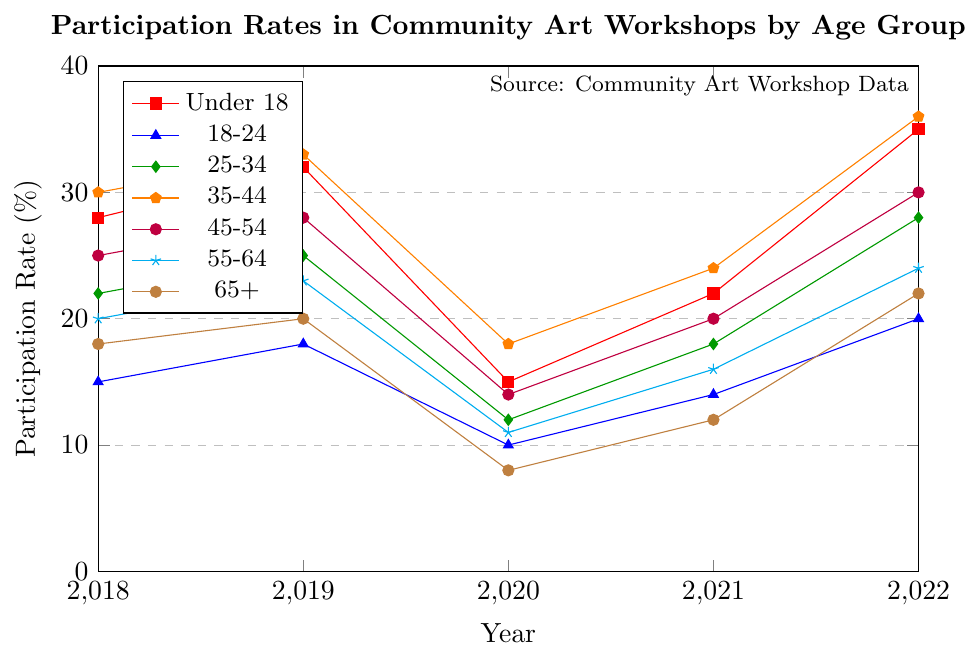What's the trend for the participation rate of the "Under 18" age group over the years? Start by observing the line plot corresponding to the "Under 18" age group, marked with a specific color. In 2018, the participation rate for the "Under 18" age group is at 28%, which then rises to 32% in 2019. It significantly drops to 15% in 2020, then recovers slightly to 22% in 2021, and finally reaches its peak at 35% in 2022.
Answer: Increasing with fluctuations Which age group shows the largest increase in participation rate from 2021 to 2022? Identify the segment from 2021 to 2022 for each age group. For Under 18, the rise is from 22% to 35% (13%). For 18-24, it's from 14% to 20% (6%). For 25-34, it's from 18% to 28% (10%). For 35-44, it's from 24% to 36% (12%). For 45-54, it's from 20% to 30% (10%). For 55-64, it's from 16% to 24% (8%). For 65+, it's from 12% to 22% (10%). The "Under 18" group has the highest increase of 13%.
Answer: Under 18 In which year did the 65+ age group have the lowest participation rate? Trace the line corresponding to the 65+ age group and identify the point with the lowest value. The years with the respective values are 2018 (18%), 2019 (20%), 2020 (8%), 2021 (12%), and 2022 (22%). The lowest value is 8%, which occurs in 2020.
Answer: 2020 What is the average participation rate for the 35-44 age group over the 5 years? Add the participation rates for the 35-44 age group from 2018 to 2022: 30%, 33%, 18%, 24%, and 36%. The sum is 30 + 33 + 18 + 24 + 36 = 141. The average is then 141 / 5 = 28.2%.
Answer: 28.2% Which age group has the most consistent participation rate from 2018 to 2022? Evaluate the fluctuation (difference between highest and lowest rates) for each age group. Under 18: 35%-15%=20%, 18-24: 20%-10%=10%, 25-34: 28%-12%=16%, 35-44: 36%-18%=18%, 45-54: 30%-14%=16%, 55-64: 24%-11%=13%, 65+: 22%-8%=14%. The 18-24 age group has the smallest range, indicating the most consistent participation.
Answer: 18-24 How did the pandemic year (2020) affect the participation rates across all age groups? Look at the participation rates for all age groups in 2020. The values are: Under 18 (15%), 18-24 (10%), 25-34 (12%), 35-44 (18%), 45-54 (14%), 55-64 (11%), 65+ (8%). Compared to other years, 2020 generally shows lower participation rates, suggesting a significant drop in participation across all age groups during the pandemic year.
Answer: Decreased across all What is the difference in the participation rate between the oldest (65+) and the youngest (Under 18) age groups in 2022? For 2022, the participation rates are 35% for Under 18 and 22% for 65+. The difference is calculated as 35% - 22% = 13%.
Answer: 13% Between which consecutive years did the 25-34 age group see the largest drop in participation? Evaluate the drop between consecutive years for the 25-34 age group: 2018-2019: 25-22= +3%, 2019-2020: 25-12= 13% drop, 2020-2021: 18-12= +6%, 2021-2022: 28-18= -10%. The largest drop is between 2019 and 2020, with a decrease of 13%.
Answer: 2019 to 2020 How does the participation trend for the 55-64 age group compare to that of the 45-54 age group over the years? Analyze the lines corresponding to these age groups. Both show dips in 2020, but the 45-54 group starts higher and rebounds to a higher peak (30%) in 2022, whereas the 55-64 group starts lower and peaks at 24% in 2022. Both show a general downtrend until 2020 and then an upward trend post-2020, but the 45-54 group has a larger range of values.
Answer: Similar trend with larger range for 45-54 